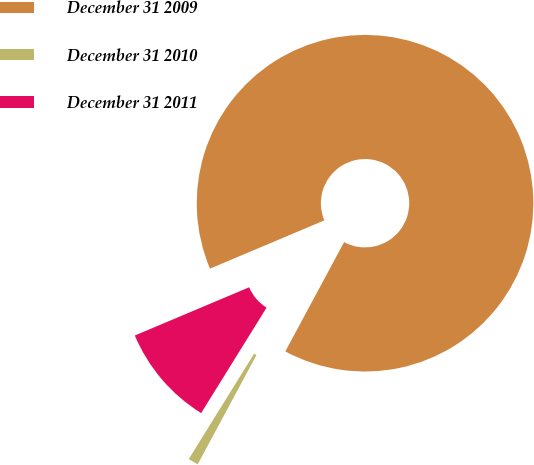Convert chart. <chart><loc_0><loc_0><loc_500><loc_500><pie_chart><fcel>December 31 2009<fcel>December 31 2010<fcel>December 31 2011<nl><fcel>89.21%<fcel>0.98%<fcel>9.81%<nl></chart> 